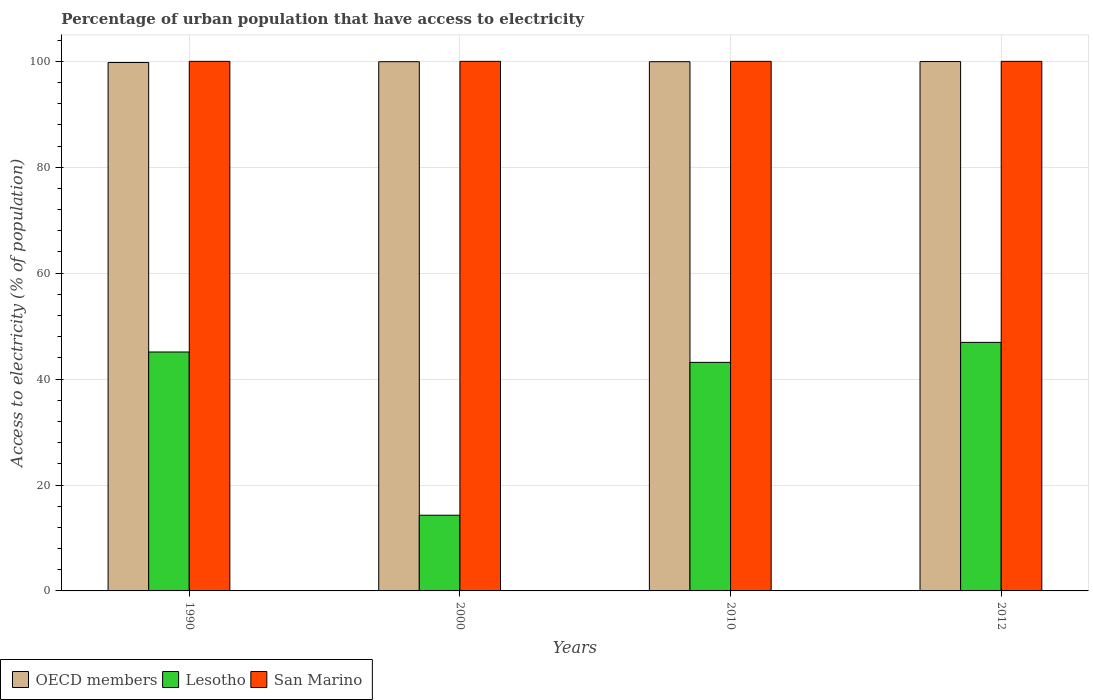How many different coloured bars are there?
Offer a very short reply. 3. How many groups of bars are there?
Provide a succinct answer. 4. How many bars are there on the 2nd tick from the right?
Offer a terse response. 3. What is the label of the 4th group of bars from the left?
Keep it short and to the point. 2012. In how many cases, is the number of bars for a given year not equal to the number of legend labels?
Offer a very short reply. 0. What is the percentage of urban population that have access to electricity in OECD members in 2012?
Provide a short and direct response. 99.96. Across all years, what is the maximum percentage of urban population that have access to electricity in Lesotho?
Your answer should be compact. 46.93. Across all years, what is the minimum percentage of urban population that have access to electricity in Lesotho?
Ensure brevity in your answer.  14.29. In which year was the percentage of urban population that have access to electricity in San Marino maximum?
Give a very brief answer. 1990. What is the total percentage of urban population that have access to electricity in San Marino in the graph?
Provide a short and direct response. 400. What is the difference between the percentage of urban population that have access to electricity in San Marino in 2010 and the percentage of urban population that have access to electricity in OECD members in 1990?
Offer a terse response. 0.22. What is the average percentage of urban population that have access to electricity in Lesotho per year?
Give a very brief answer. 37.38. In the year 1990, what is the difference between the percentage of urban population that have access to electricity in San Marino and percentage of urban population that have access to electricity in OECD members?
Provide a short and direct response. 0.22. What is the ratio of the percentage of urban population that have access to electricity in Lesotho in 2000 to that in 2012?
Ensure brevity in your answer.  0.3. What is the difference between the highest and the second highest percentage of urban population that have access to electricity in Lesotho?
Your response must be concise. 1.81. What is the difference between the highest and the lowest percentage of urban population that have access to electricity in Lesotho?
Offer a very short reply. 32.64. Is the sum of the percentage of urban population that have access to electricity in OECD members in 1990 and 2010 greater than the maximum percentage of urban population that have access to electricity in Lesotho across all years?
Ensure brevity in your answer.  Yes. What does the 2nd bar from the left in 2010 represents?
Offer a terse response. Lesotho. What does the 3rd bar from the right in 2012 represents?
Make the answer very short. OECD members. Is it the case that in every year, the sum of the percentage of urban population that have access to electricity in San Marino and percentage of urban population that have access to electricity in OECD members is greater than the percentage of urban population that have access to electricity in Lesotho?
Offer a terse response. Yes. Are all the bars in the graph horizontal?
Keep it short and to the point. No. How many years are there in the graph?
Offer a terse response. 4. What is the difference between two consecutive major ticks on the Y-axis?
Make the answer very short. 20. Does the graph contain any zero values?
Your response must be concise. No. Does the graph contain grids?
Your answer should be compact. Yes. Where does the legend appear in the graph?
Offer a terse response. Bottom left. How are the legend labels stacked?
Provide a short and direct response. Horizontal. What is the title of the graph?
Give a very brief answer. Percentage of urban population that have access to electricity. What is the label or title of the Y-axis?
Ensure brevity in your answer.  Access to electricity (% of population). What is the Access to electricity (% of population) of OECD members in 1990?
Your answer should be very brief. 99.78. What is the Access to electricity (% of population) of Lesotho in 1990?
Make the answer very short. 45.12. What is the Access to electricity (% of population) in OECD members in 2000?
Provide a succinct answer. 99.93. What is the Access to electricity (% of population) in Lesotho in 2000?
Keep it short and to the point. 14.29. What is the Access to electricity (% of population) in OECD members in 2010?
Ensure brevity in your answer.  99.93. What is the Access to electricity (% of population) in Lesotho in 2010?
Your answer should be very brief. 43.16. What is the Access to electricity (% of population) in OECD members in 2012?
Provide a short and direct response. 99.96. What is the Access to electricity (% of population) of Lesotho in 2012?
Offer a terse response. 46.93. What is the Access to electricity (% of population) in San Marino in 2012?
Your answer should be very brief. 100. Across all years, what is the maximum Access to electricity (% of population) in OECD members?
Ensure brevity in your answer.  99.96. Across all years, what is the maximum Access to electricity (% of population) of Lesotho?
Your answer should be very brief. 46.93. Across all years, what is the minimum Access to electricity (% of population) of OECD members?
Offer a very short reply. 99.78. Across all years, what is the minimum Access to electricity (% of population) of Lesotho?
Give a very brief answer. 14.29. What is the total Access to electricity (% of population) of OECD members in the graph?
Your answer should be compact. 399.6. What is the total Access to electricity (% of population) of Lesotho in the graph?
Give a very brief answer. 149.5. What is the total Access to electricity (% of population) in San Marino in the graph?
Offer a very short reply. 400. What is the difference between the Access to electricity (% of population) of OECD members in 1990 and that in 2000?
Your answer should be compact. -0.15. What is the difference between the Access to electricity (% of population) in Lesotho in 1990 and that in 2000?
Keep it short and to the point. 30.82. What is the difference between the Access to electricity (% of population) of San Marino in 1990 and that in 2000?
Offer a terse response. 0. What is the difference between the Access to electricity (% of population) of OECD members in 1990 and that in 2010?
Your answer should be compact. -0.15. What is the difference between the Access to electricity (% of population) in Lesotho in 1990 and that in 2010?
Provide a succinct answer. 1.96. What is the difference between the Access to electricity (% of population) in OECD members in 1990 and that in 2012?
Ensure brevity in your answer.  -0.18. What is the difference between the Access to electricity (% of population) of Lesotho in 1990 and that in 2012?
Make the answer very short. -1.81. What is the difference between the Access to electricity (% of population) in San Marino in 1990 and that in 2012?
Keep it short and to the point. 0. What is the difference between the Access to electricity (% of population) in OECD members in 2000 and that in 2010?
Keep it short and to the point. -0. What is the difference between the Access to electricity (% of population) in Lesotho in 2000 and that in 2010?
Your answer should be very brief. -28.86. What is the difference between the Access to electricity (% of population) in OECD members in 2000 and that in 2012?
Ensure brevity in your answer.  -0.03. What is the difference between the Access to electricity (% of population) in Lesotho in 2000 and that in 2012?
Provide a short and direct response. -32.64. What is the difference between the Access to electricity (% of population) of San Marino in 2000 and that in 2012?
Offer a terse response. 0. What is the difference between the Access to electricity (% of population) in OECD members in 2010 and that in 2012?
Provide a succinct answer. -0.03. What is the difference between the Access to electricity (% of population) of Lesotho in 2010 and that in 2012?
Provide a succinct answer. -3.77. What is the difference between the Access to electricity (% of population) in OECD members in 1990 and the Access to electricity (% of population) in Lesotho in 2000?
Your answer should be compact. 85.49. What is the difference between the Access to electricity (% of population) of OECD members in 1990 and the Access to electricity (% of population) of San Marino in 2000?
Your answer should be compact. -0.22. What is the difference between the Access to electricity (% of population) in Lesotho in 1990 and the Access to electricity (% of population) in San Marino in 2000?
Provide a succinct answer. -54.88. What is the difference between the Access to electricity (% of population) in OECD members in 1990 and the Access to electricity (% of population) in Lesotho in 2010?
Keep it short and to the point. 56.62. What is the difference between the Access to electricity (% of population) of OECD members in 1990 and the Access to electricity (% of population) of San Marino in 2010?
Your response must be concise. -0.22. What is the difference between the Access to electricity (% of population) of Lesotho in 1990 and the Access to electricity (% of population) of San Marino in 2010?
Provide a short and direct response. -54.88. What is the difference between the Access to electricity (% of population) of OECD members in 1990 and the Access to electricity (% of population) of Lesotho in 2012?
Provide a succinct answer. 52.85. What is the difference between the Access to electricity (% of population) in OECD members in 1990 and the Access to electricity (% of population) in San Marino in 2012?
Offer a very short reply. -0.22. What is the difference between the Access to electricity (% of population) of Lesotho in 1990 and the Access to electricity (% of population) of San Marino in 2012?
Provide a succinct answer. -54.88. What is the difference between the Access to electricity (% of population) of OECD members in 2000 and the Access to electricity (% of population) of Lesotho in 2010?
Make the answer very short. 56.77. What is the difference between the Access to electricity (% of population) of OECD members in 2000 and the Access to electricity (% of population) of San Marino in 2010?
Provide a succinct answer. -0.07. What is the difference between the Access to electricity (% of population) of Lesotho in 2000 and the Access to electricity (% of population) of San Marino in 2010?
Offer a terse response. -85.71. What is the difference between the Access to electricity (% of population) in OECD members in 2000 and the Access to electricity (% of population) in Lesotho in 2012?
Provide a succinct answer. 53. What is the difference between the Access to electricity (% of population) of OECD members in 2000 and the Access to electricity (% of population) of San Marino in 2012?
Your response must be concise. -0.07. What is the difference between the Access to electricity (% of population) of Lesotho in 2000 and the Access to electricity (% of population) of San Marino in 2012?
Make the answer very short. -85.71. What is the difference between the Access to electricity (% of population) in OECD members in 2010 and the Access to electricity (% of population) in Lesotho in 2012?
Your response must be concise. 53. What is the difference between the Access to electricity (% of population) in OECD members in 2010 and the Access to electricity (% of population) in San Marino in 2012?
Offer a terse response. -0.07. What is the difference between the Access to electricity (% of population) of Lesotho in 2010 and the Access to electricity (% of population) of San Marino in 2012?
Provide a succinct answer. -56.84. What is the average Access to electricity (% of population) of OECD members per year?
Give a very brief answer. 99.9. What is the average Access to electricity (% of population) of Lesotho per year?
Your answer should be very brief. 37.38. In the year 1990, what is the difference between the Access to electricity (% of population) in OECD members and Access to electricity (% of population) in Lesotho?
Provide a succinct answer. 54.66. In the year 1990, what is the difference between the Access to electricity (% of population) in OECD members and Access to electricity (% of population) in San Marino?
Your response must be concise. -0.22. In the year 1990, what is the difference between the Access to electricity (% of population) in Lesotho and Access to electricity (% of population) in San Marino?
Keep it short and to the point. -54.88. In the year 2000, what is the difference between the Access to electricity (% of population) in OECD members and Access to electricity (% of population) in Lesotho?
Keep it short and to the point. 85.64. In the year 2000, what is the difference between the Access to electricity (% of population) in OECD members and Access to electricity (% of population) in San Marino?
Keep it short and to the point. -0.07. In the year 2000, what is the difference between the Access to electricity (% of population) in Lesotho and Access to electricity (% of population) in San Marino?
Give a very brief answer. -85.71. In the year 2010, what is the difference between the Access to electricity (% of population) of OECD members and Access to electricity (% of population) of Lesotho?
Your answer should be very brief. 56.77. In the year 2010, what is the difference between the Access to electricity (% of population) of OECD members and Access to electricity (% of population) of San Marino?
Provide a short and direct response. -0.07. In the year 2010, what is the difference between the Access to electricity (% of population) in Lesotho and Access to electricity (% of population) in San Marino?
Ensure brevity in your answer.  -56.84. In the year 2012, what is the difference between the Access to electricity (% of population) of OECD members and Access to electricity (% of population) of Lesotho?
Offer a very short reply. 53.03. In the year 2012, what is the difference between the Access to electricity (% of population) in OECD members and Access to electricity (% of population) in San Marino?
Make the answer very short. -0.04. In the year 2012, what is the difference between the Access to electricity (% of population) of Lesotho and Access to electricity (% of population) of San Marino?
Make the answer very short. -53.07. What is the ratio of the Access to electricity (% of population) in OECD members in 1990 to that in 2000?
Your answer should be very brief. 1. What is the ratio of the Access to electricity (% of population) in Lesotho in 1990 to that in 2000?
Keep it short and to the point. 3.16. What is the ratio of the Access to electricity (% of population) of Lesotho in 1990 to that in 2010?
Provide a short and direct response. 1.05. What is the ratio of the Access to electricity (% of population) of San Marino in 1990 to that in 2010?
Your answer should be very brief. 1. What is the ratio of the Access to electricity (% of population) in Lesotho in 1990 to that in 2012?
Offer a very short reply. 0.96. What is the ratio of the Access to electricity (% of population) of San Marino in 1990 to that in 2012?
Provide a succinct answer. 1. What is the ratio of the Access to electricity (% of population) in OECD members in 2000 to that in 2010?
Make the answer very short. 1. What is the ratio of the Access to electricity (% of population) of Lesotho in 2000 to that in 2010?
Ensure brevity in your answer.  0.33. What is the ratio of the Access to electricity (% of population) in Lesotho in 2000 to that in 2012?
Your response must be concise. 0.3. What is the ratio of the Access to electricity (% of population) in San Marino in 2000 to that in 2012?
Provide a succinct answer. 1. What is the ratio of the Access to electricity (% of population) in Lesotho in 2010 to that in 2012?
Your answer should be very brief. 0.92. What is the difference between the highest and the second highest Access to electricity (% of population) in OECD members?
Offer a terse response. 0.03. What is the difference between the highest and the second highest Access to electricity (% of population) in Lesotho?
Make the answer very short. 1.81. What is the difference between the highest and the lowest Access to electricity (% of population) of OECD members?
Offer a terse response. 0.18. What is the difference between the highest and the lowest Access to electricity (% of population) in Lesotho?
Offer a very short reply. 32.64. 